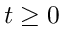<formula> <loc_0><loc_0><loc_500><loc_500>t \geq 0</formula> 